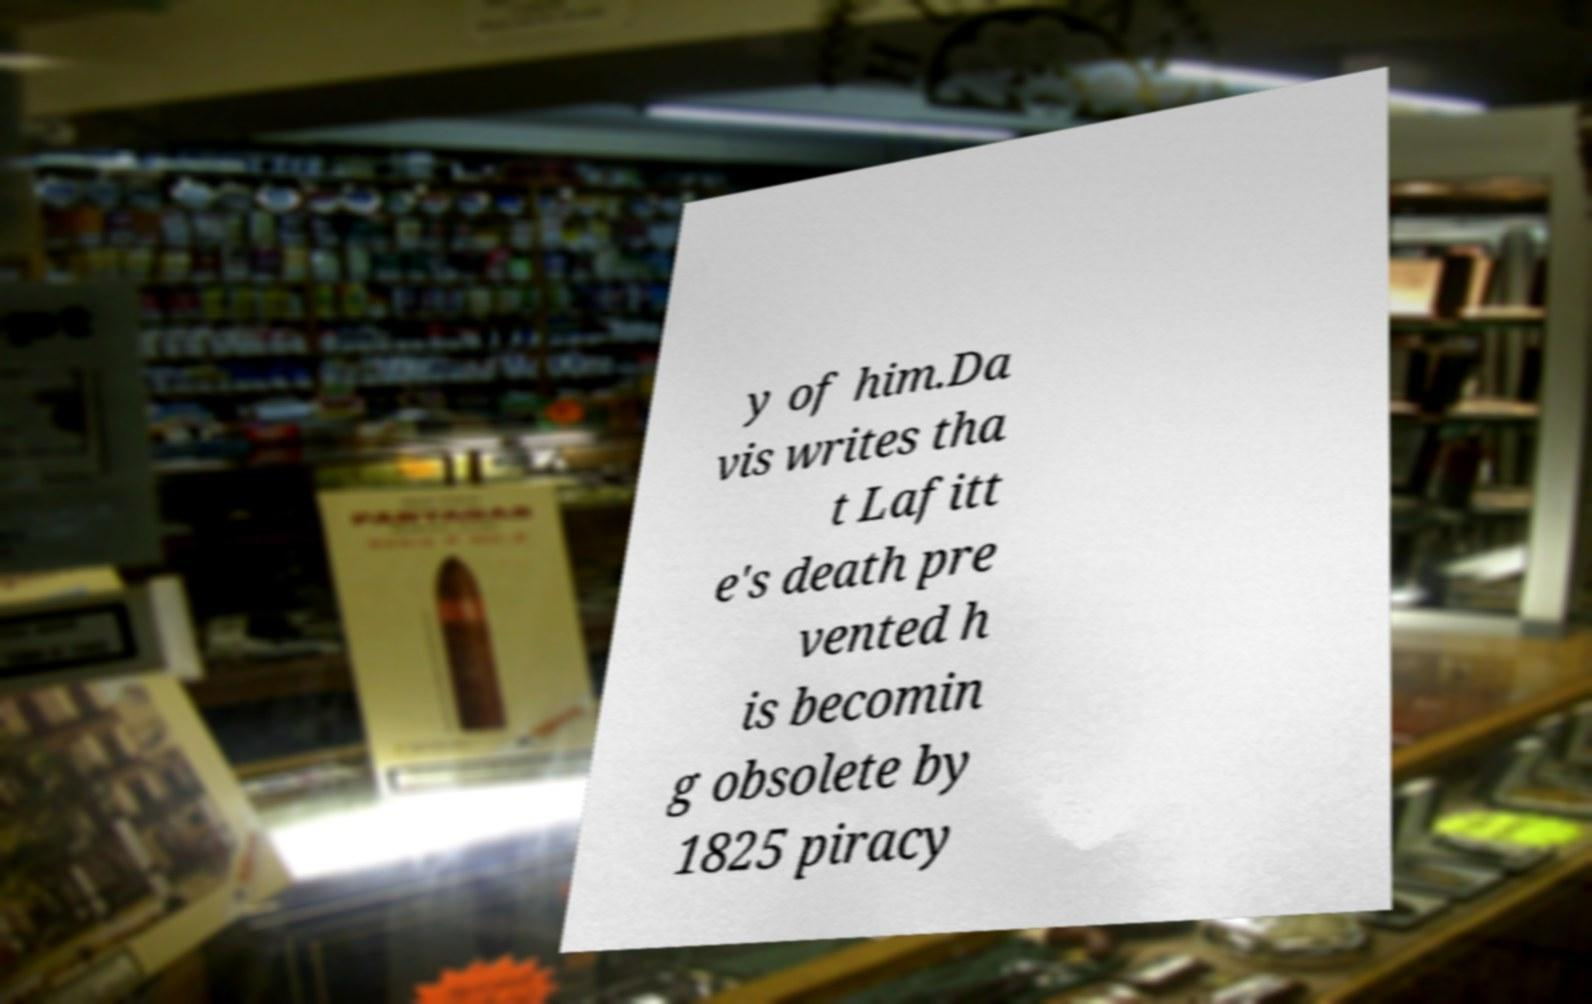Can you read and provide the text displayed in the image?This photo seems to have some interesting text. Can you extract and type it out for me? y of him.Da vis writes tha t Lafitt e's death pre vented h is becomin g obsolete by 1825 piracy 